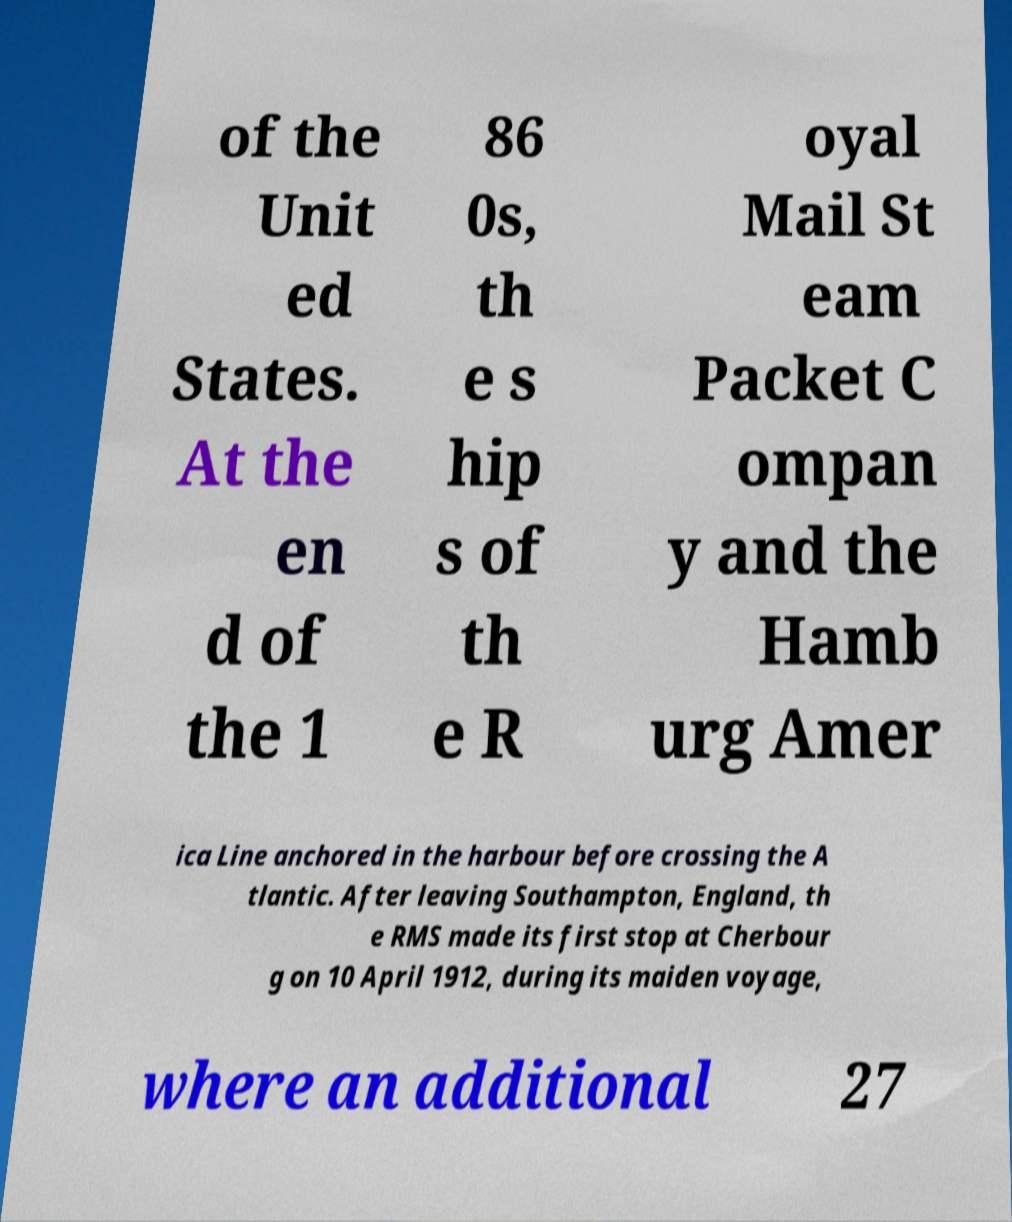Can you read and provide the text displayed in the image?This photo seems to have some interesting text. Can you extract and type it out for me? of the Unit ed States. At the en d of the 1 86 0s, th e s hip s of th e R oyal Mail St eam Packet C ompan y and the Hamb urg Amer ica Line anchored in the harbour before crossing the A tlantic. After leaving Southampton, England, th e RMS made its first stop at Cherbour g on 10 April 1912, during its maiden voyage, where an additional 27 